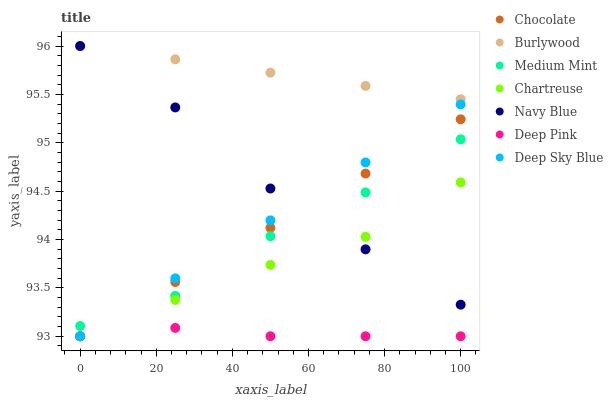Does Deep Pink have the minimum area under the curve?
Answer yes or no. Yes. Does Burlywood have the maximum area under the curve?
Answer yes or no. Yes. Does Burlywood have the minimum area under the curve?
Answer yes or no. No. Does Deep Pink have the maximum area under the curve?
Answer yes or no. No. Is Burlywood the smoothest?
Answer yes or no. Yes. Is Medium Mint the roughest?
Answer yes or no. Yes. Is Deep Pink the smoothest?
Answer yes or no. No. Is Deep Pink the roughest?
Answer yes or no. No. Does Deep Pink have the lowest value?
Answer yes or no. Yes. Does Burlywood have the lowest value?
Answer yes or no. No. Does Navy Blue have the highest value?
Answer yes or no. Yes. Does Deep Pink have the highest value?
Answer yes or no. No. Is Deep Pink less than Navy Blue?
Answer yes or no. Yes. Is Burlywood greater than Deep Sky Blue?
Answer yes or no. Yes. Does Deep Pink intersect Chartreuse?
Answer yes or no. Yes. Is Deep Pink less than Chartreuse?
Answer yes or no. No. Is Deep Pink greater than Chartreuse?
Answer yes or no. No. Does Deep Pink intersect Navy Blue?
Answer yes or no. No. 